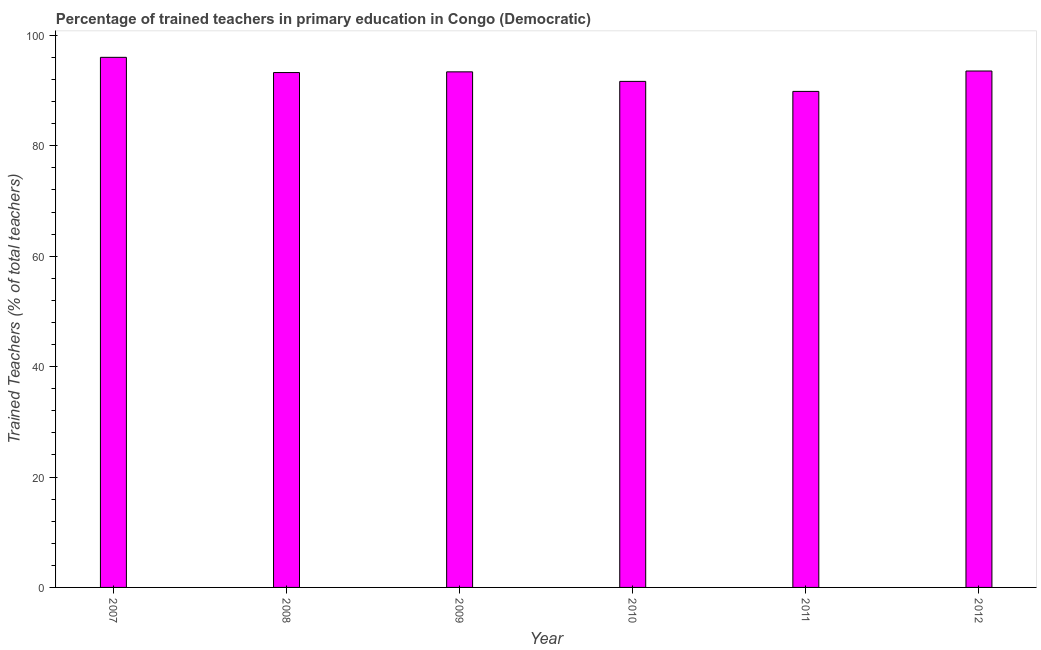Does the graph contain any zero values?
Give a very brief answer. No. What is the title of the graph?
Make the answer very short. Percentage of trained teachers in primary education in Congo (Democratic). What is the label or title of the X-axis?
Ensure brevity in your answer.  Year. What is the label or title of the Y-axis?
Your answer should be compact. Trained Teachers (% of total teachers). What is the percentage of trained teachers in 2011?
Give a very brief answer. 89.85. Across all years, what is the maximum percentage of trained teachers?
Ensure brevity in your answer.  96.02. Across all years, what is the minimum percentage of trained teachers?
Keep it short and to the point. 89.85. In which year was the percentage of trained teachers minimum?
Offer a very short reply. 2011. What is the sum of the percentage of trained teachers?
Your answer should be very brief. 557.75. What is the difference between the percentage of trained teachers in 2008 and 2010?
Give a very brief answer. 1.6. What is the average percentage of trained teachers per year?
Provide a succinct answer. 92.96. What is the median percentage of trained teachers?
Ensure brevity in your answer.  93.33. Do a majority of the years between 2007 and 2012 (inclusive) have percentage of trained teachers greater than 60 %?
Offer a terse response. Yes. What is the ratio of the percentage of trained teachers in 2007 to that in 2010?
Your answer should be compact. 1.05. Is the percentage of trained teachers in 2011 less than that in 2012?
Provide a short and direct response. Yes. Is the difference between the percentage of trained teachers in 2007 and 2009 greater than the difference between any two years?
Keep it short and to the point. No. What is the difference between the highest and the second highest percentage of trained teachers?
Your response must be concise. 2.48. Is the sum of the percentage of trained teachers in 2008 and 2010 greater than the maximum percentage of trained teachers across all years?
Make the answer very short. Yes. What is the difference between the highest and the lowest percentage of trained teachers?
Your answer should be compact. 6.17. How many bars are there?
Offer a very short reply. 6. How many years are there in the graph?
Your answer should be very brief. 6. What is the difference between two consecutive major ticks on the Y-axis?
Your response must be concise. 20. Are the values on the major ticks of Y-axis written in scientific E-notation?
Keep it short and to the point. No. What is the Trained Teachers (% of total teachers) of 2007?
Give a very brief answer. 96.02. What is the Trained Teachers (% of total teachers) of 2008?
Offer a very short reply. 93.27. What is the Trained Teachers (% of total teachers) in 2009?
Ensure brevity in your answer.  93.39. What is the Trained Teachers (% of total teachers) of 2010?
Ensure brevity in your answer.  91.67. What is the Trained Teachers (% of total teachers) of 2011?
Your response must be concise. 89.85. What is the Trained Teachers (% of total teachers) in 2012?
Your response must be concise. 93.55. What is the difference between the Trained Teachers (% of total teachers) in 2007 and 2008?
Keep it short and to the point. 2.76. What is the difference between the Trained Teachers (% of total teachers) in 2007 and 2009?
Keep it short and to the point. 2.63. What is the difference between the Trained Teachers (% of total teachers) in 2007 and 2010?
Your response must be concise. 4.36. What is the difference between the Trained Teachers (% of total teachers) in 2007 and 2011?
Provide a succinct answer. 6.17. What is the difference between the Trained Teachers (% of total teachers) in 2007 and 2012?
Provide a short and direct response. 2.48. What is the difference between the Trained Teachers (% of total teachers) in 2008 and 2009?
Offer a very short reply. -0.13. What is the difference between the Trained Teachers (% of total teachers) in 2008 and 2010?
Your response must be concise. 1.6. What is the difference between the Trained Teachers (% of total teachers) in 2008 and 2011?
Make the answer very short. 3.41. What is the difference between the Trained Teachers (% of total teachers) in 2008 and 2012?
Your answer should be very brief. -0.28. What is the difference between the Trained Teachers (% of total teachers) in 2009 and 2010?
Give a very brief answer. 1.73. What is the difference between the Trained Teachers (% of total teachers) in 2009 and 2011?
Provide a short and direct response. 3.54. What is the difference between the Trained Teachers (% of total teachers) in 2009 and 2012?
Offer a very short reply. -0.15. What is the difference between the Trained Teachers (% of total teachers) in 2010 and 2011?
Ensure brevity in your answer.  1.81. What is the difference between the Trained Teachers (% of total teachers) in 2010 and 2012?
Provide a succinct answer. -1.88. What is the difference between the Trained Teachers (% of total teachers) in 2011 and 2012?
Keep it short and to the point. -3.69. What is the ratio of the Trained Teachers (% of total teachers) in 2007 to that in 2009?
Your answer should be compact. 1.03. What is the ratio of the Trained Teachers (% of total teachers) in 2007 to that in 2010?
Provide a short and direct response. 1.05. What is the ratio of the Trained Teachers (% of total teachers) in 2007 to that in 2011?
Make the answer very short. 1.07. What is the ratio of the Trained Teachers (% of total teachers) in 2008 to that in 2011?
Your response must be concise. 1.04. What is the ratio of the Trained Teachers (% of total teachers) in 2009 to that in 2011?
Offer a terse response. 1.04. What is the ratio of the Trained Teachers (% of total teachers) in 2009 to that in 2012?
Give a very brief answer. 1. What is the ratio of the Trained Teachers (% of total teachers) in 2010 to that in 2011?
Provide a succinct answer. 1.02. 